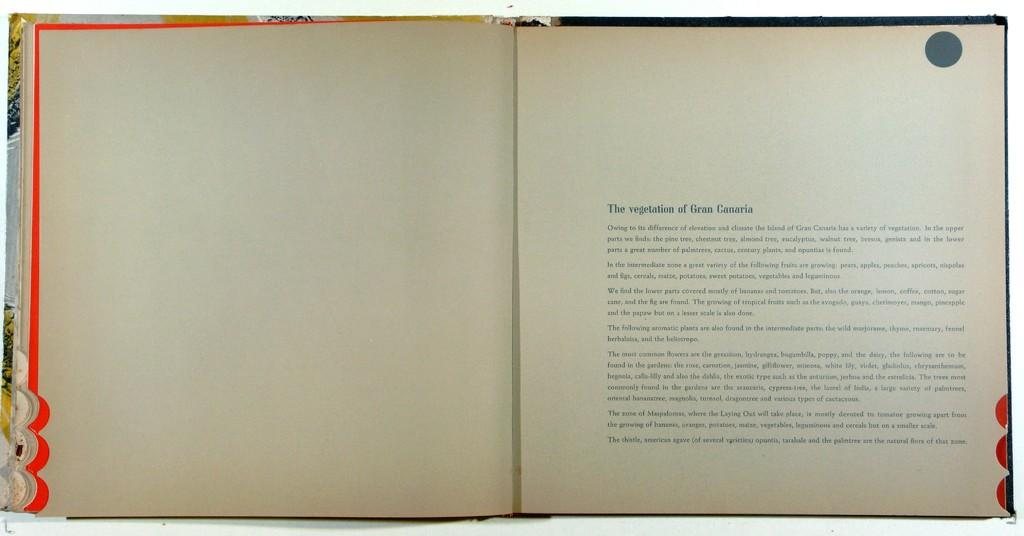<image>
Summarize the visual content of the image. A book is open to a chapter entitled 'The vegetation of Gran Canaria' 